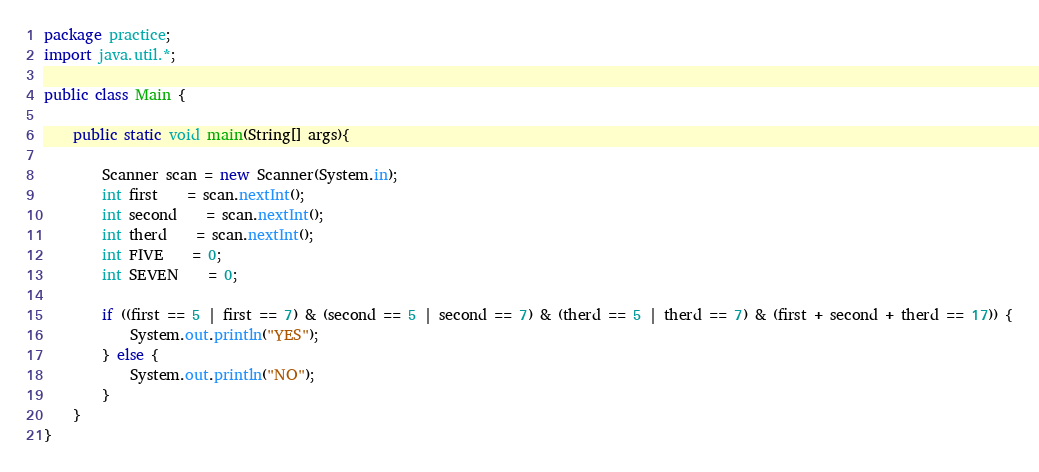<code> <loc_0><loc_0><loc_500><loc_500><_Java_>package practice;
import java.util.*;

public class Main {

	public static void main(String[] args){

		Scanner scan = new Scanner(System.in);
		int first	= scan.nextInt();
		int second	= scan.nextInt();
		int therd	= scan.nextInt();
		int FIVE	= 0;
		int SEVEN	= 0;
		
		if ((first == 5 | first == 7) & (second == 5 | second == 7) & (therd == 5 | therd == 7) & (first + second + therd == 17)) {
			System.out.println("YES");
		} else {
			System.out.println("NO");
		}
	}
}</code> 